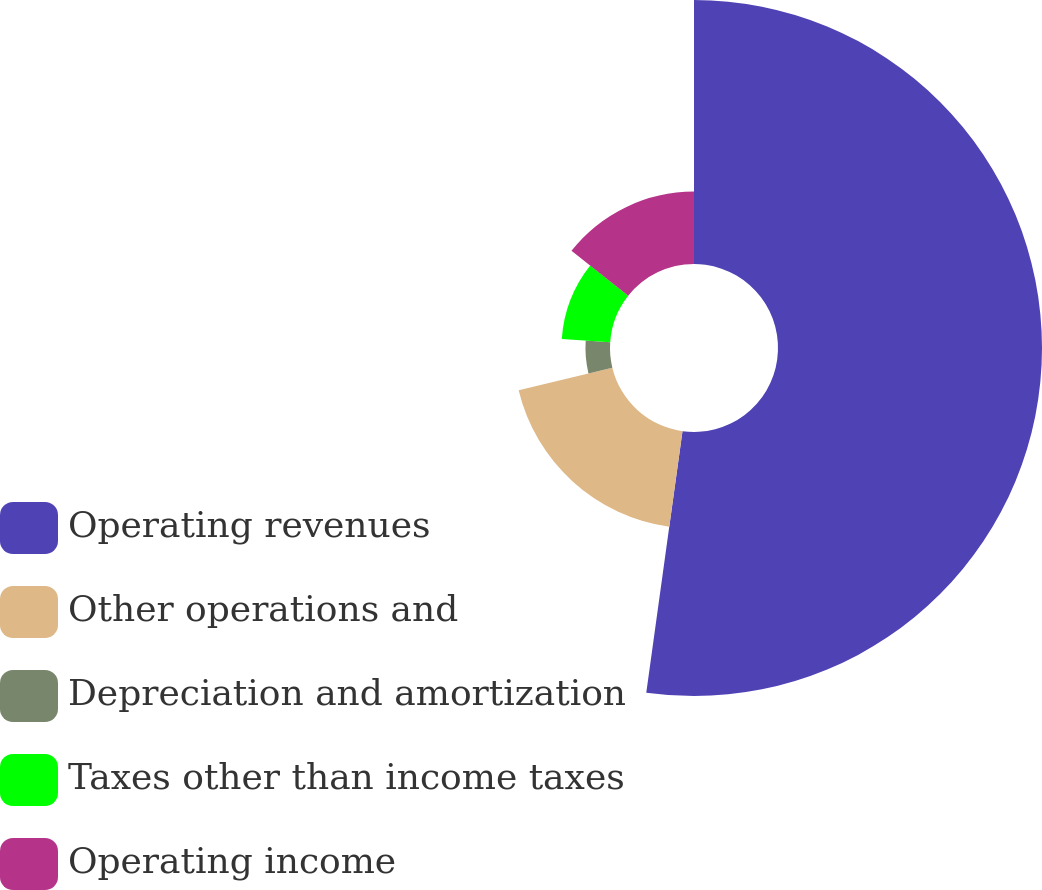Convert chart. <chart><loc_0><loc_0><loc_500><loc_500><pie_chart><fcel>Operating revenues<fcel>Other operations and<fcel>Depreciation and amortization<fcel>Taxes other than income taxes<fcel>Operating income<nl><fcel>52.19%<fcel>19.05%<fcel>4.85%<fcel>9.59%<fcel>14.32%<nl></chart> 